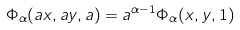<formula> <loc_0><loc_0><loc_500><loc_500>\Phi _ { \alpha } ( a x , a y , a ) = a ^ { \alpha - 1 } \Phi _ { \alpha } ( x , y , 1 )</formula> 